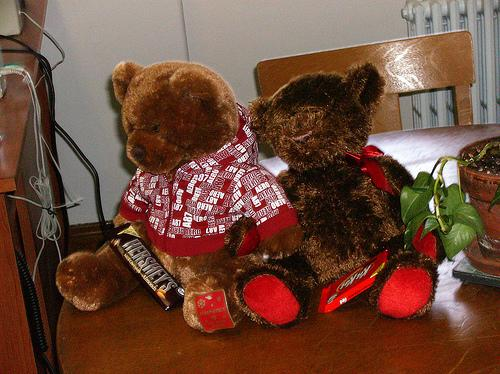Describe the scene involving the teddy bears and their features. Two brown teddy bears sitting on a table, one wearing a red jacket and having red paw pads, while the other bear has a red ribbon tied to its neck. What kind of plant is featured in the image and where is it positioned? A small house plant in a ceramic pot is positioned on the table, next to the other objects. List all the objects on the table made of wood and metal Wooden objects: table and wooden chair. Metal objects: radiator and long white electrical cord. Describe the chair type in the image, including its color and position. The chair is wooden, brown in color, and positioned near the table with the teddy bears and other objects. Explain any contrasting colors you see on the teddy bears. The teddy bear's fur is mainly brown, but one bear has red feet and wears a red jacket, and the other bear has a red ribbon tied around its neck. What are the features of the chocolate bars in the image? The Hershey's chocolate bar is wrapped in its signature brown and silver packaging, and the Kit Kat chocolate bar is wrapped in its red and white packaging. How many teddy bears are visible in the image? Two teddy bears. What is the main theme of this image? Two teddy bears sharing a table with snacks and other objects. Identify the primary objects in the image and their positions. Two brown teddy bears sitting on a table, a Hershey's chocolate bar, a Kit Kat candy bar, a potted plant, a wooden chair, a radiator, and some phone cords. What are the two types of chocolate bars present in the image? A Hershey's chocolate bar and a Kit Kat chocolate bar. 